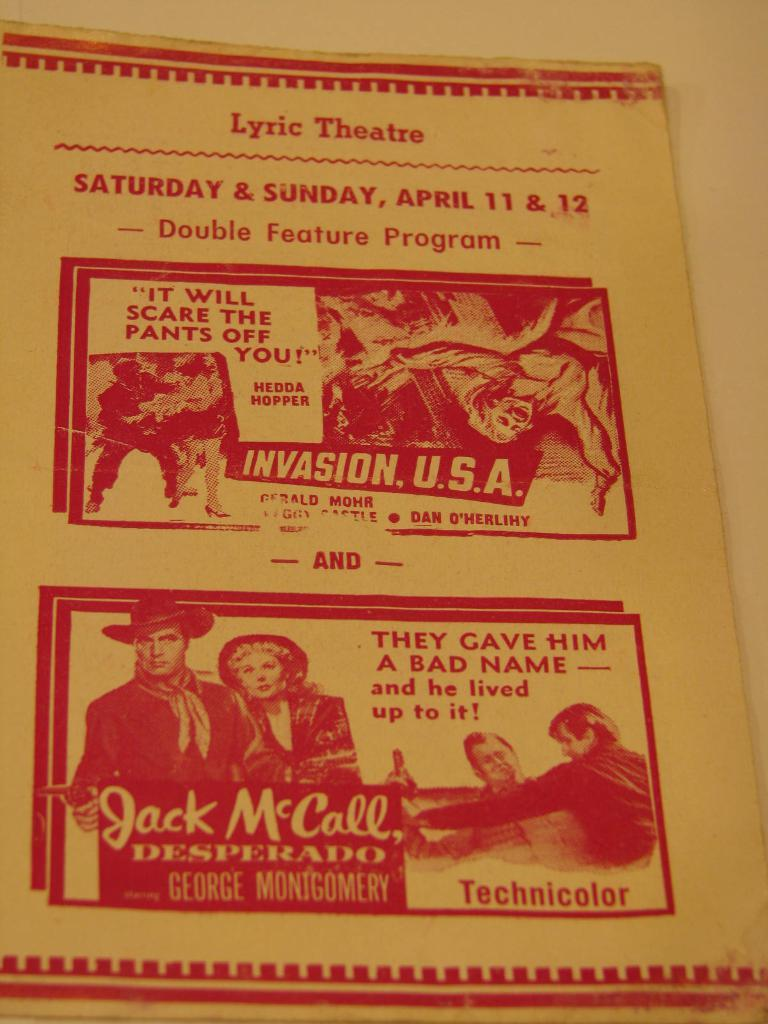Provide a one-sentence caption for the provided image. A poster announcement for the Lyric Theatre and a show on Saturday and Sunday, April 11th and 12th which is a double feature. 